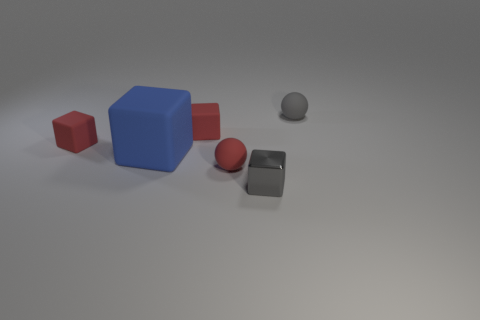Subtract all red balls. How many balls are left? 1 Add 1 red spheres. How many objects exist? 7 Subtract all tiny gray metal blocks. How many blocks are left? 3 Subtract 4 cubes. How many cubes are left? 0 Subtract 0 gray cylinders. How many objects are left? 6 Subtract all cubes. How many objects are left? 2 Subtract all yellow cubes. Subtract all yellow spheres. How many cubes are left? 4 Subtract all blue cylinders. How many gray spheres are left? 1 Subtract all large red rubber balls. Subtract all matte balls. How many objects are left? 4 Add 4 small gray blocks. How many small gray blocks are left? 5 